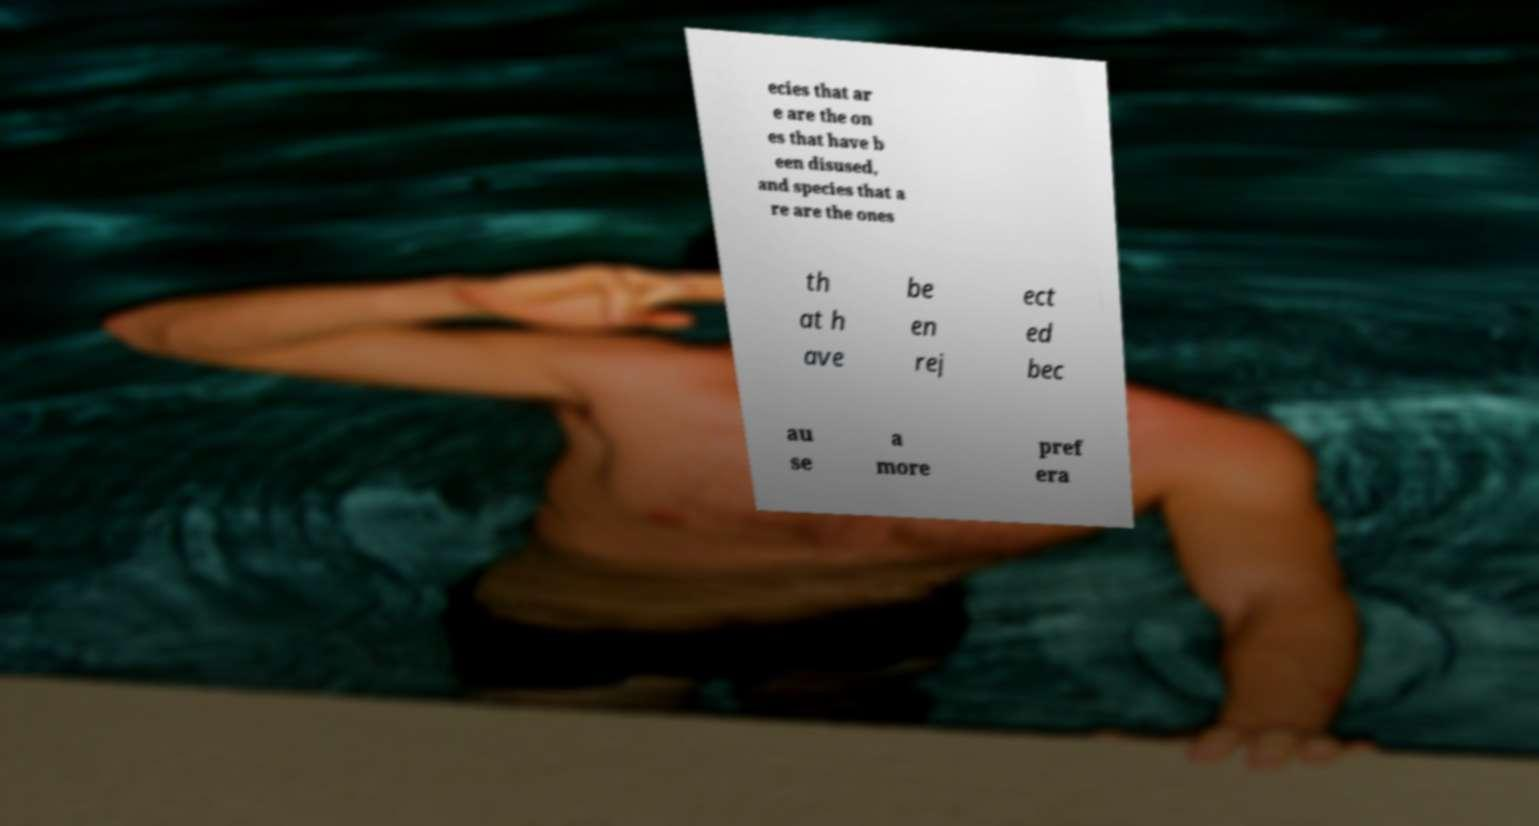Could you extract and type out the text from this image? ecies that ar e are the on es that have b een disused, and species that a re are the ones th at h ave be en rej ect ed bec au se a more pref era 